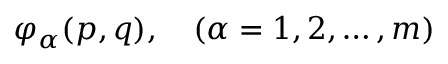Convert formula to latex. <formula><loc_0><loc_0><loc_500><loc_500>\varphi _ { \alpha } ( p , q ) , \quad ( \alpha = 1 , 2 , \dots , m )</formula> 